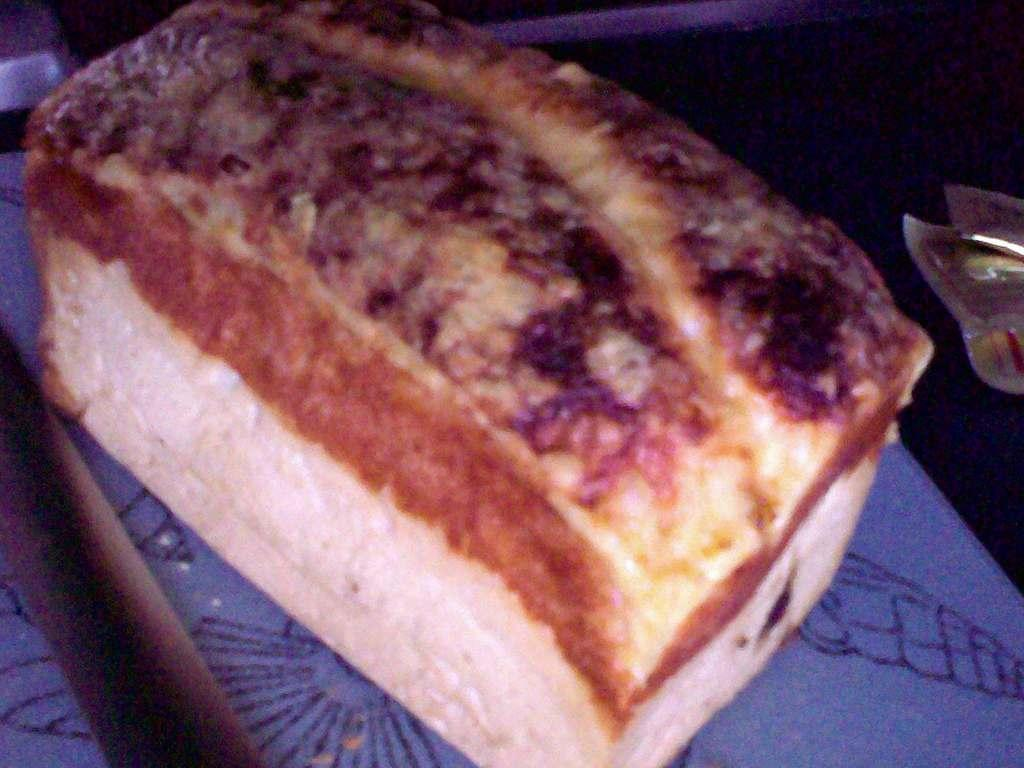What type of food is visible in the image? There is a bread in the image. What color is the surface at the bottom of the image? The surface at the bottom of the image is blue. What type of brain surgery is being performed on the bread in the image? There is no brain surgery or any medical procedure being performed on the bread in the image. 